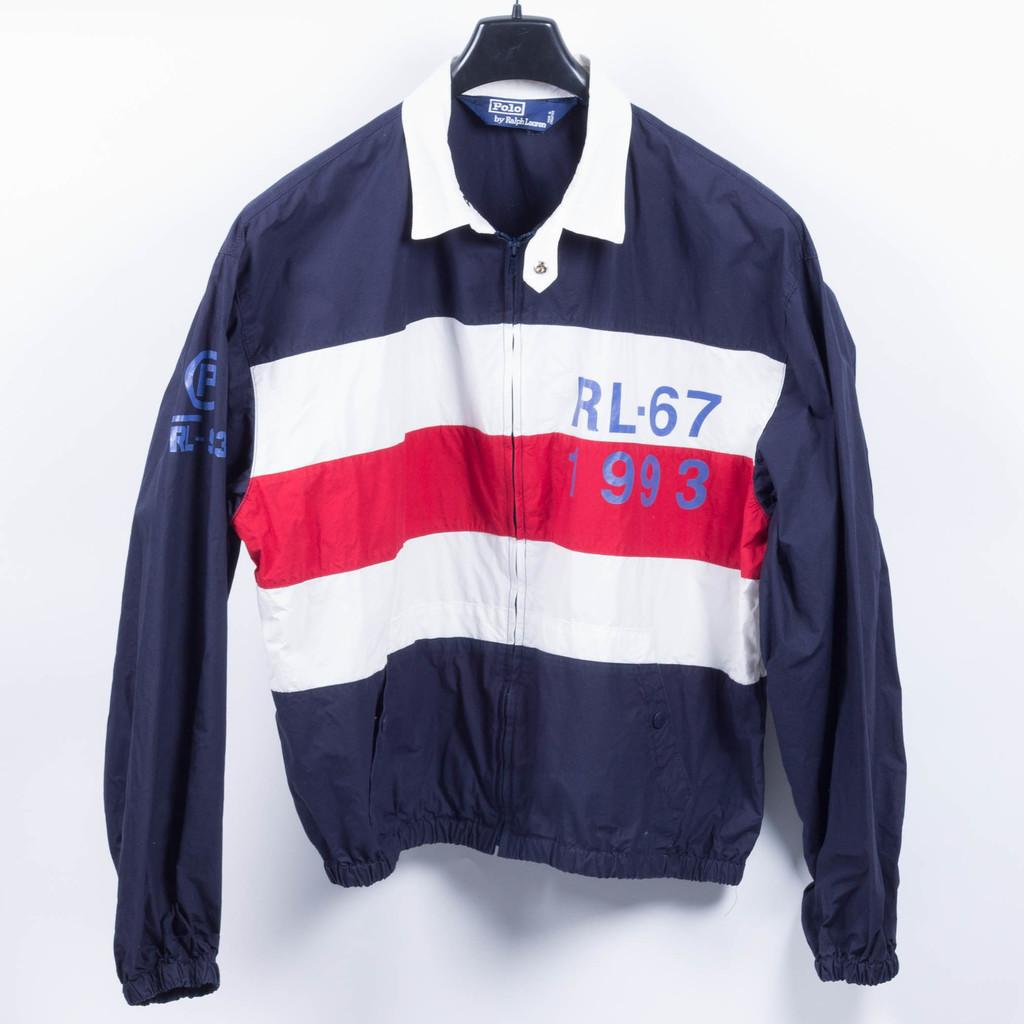<image>
Summarize the visual content of the image. A blue Ralph Laruen jacket with 2 white striples and a red striple across the mid section. 